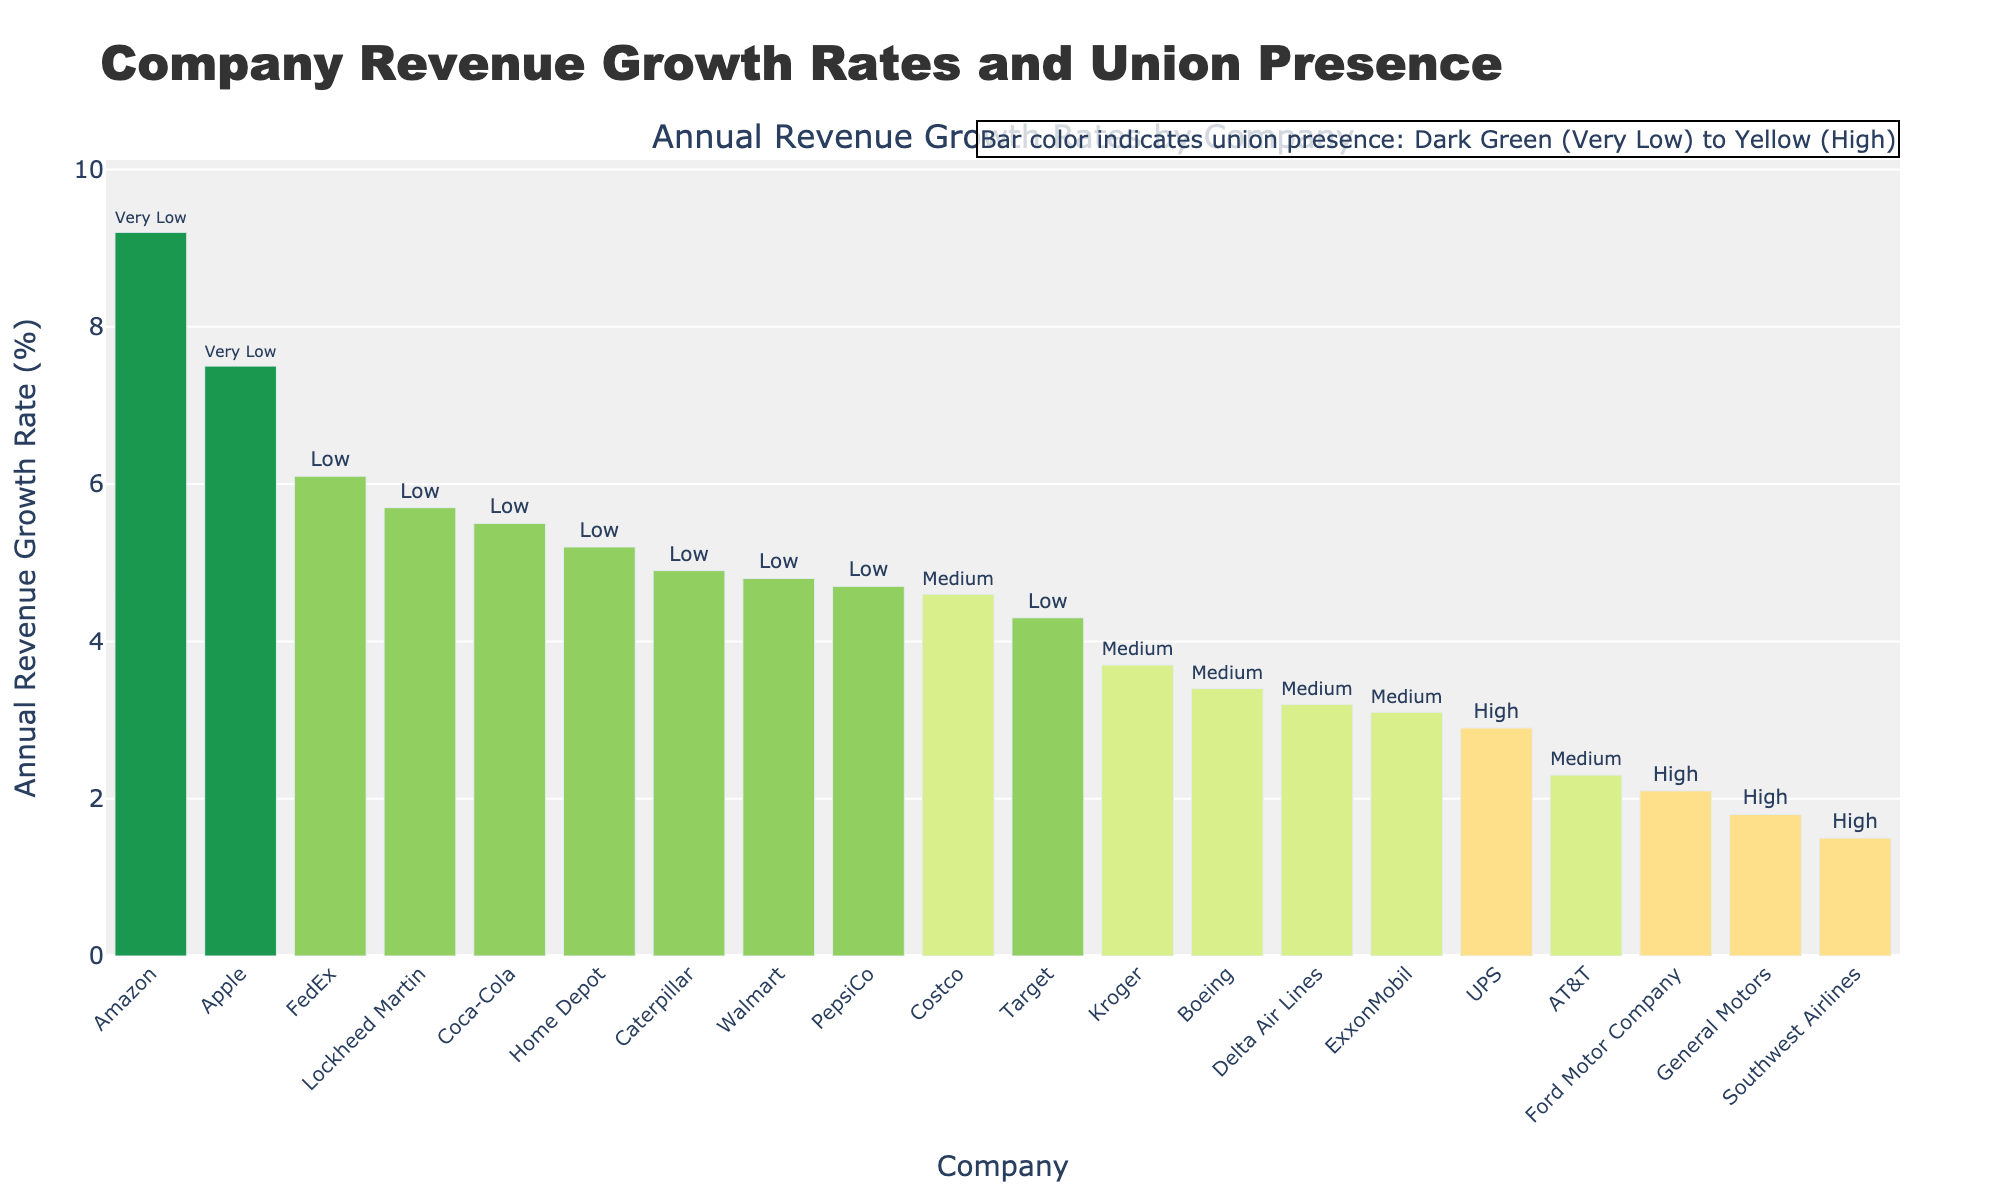Which company has the highest annual revenue growth rate? The bar representing Amazon has the highest height, indicating it has the highest annual revenue growth rate.
Answer: Amazon What is the difference in annual revenue growth rates between UPS and FedEx? The bar for UPS shows a growth rate of 2.9%, and the bar for FedEx shows a growth rate of 6.1%. The difference is 6.1% - 2.9% = 3.2%.
Answer: 3.2% What is the average annual revenue growth rate for companies with low union presence? Companies with low union presence include Walmart, Home Depot, FedEx, Lockheed Martin, Caterpillar, Target, Coca-Cola, and PepsiCo. The average is calculated as (4.8 + 5.2 + 6.1 + 5.7 + 4.9 + 4.3 + 5.5 + 4.7) / 8 = 5.15%.
Answer: 5.15% How does the annual revenue growth rate of Delta Air Lines compare to that of Boeing? Delta Air Lines has a growth rate of 3.2%, while Boeing has a growth rate of 3.4%. Boeing's growth rate is higher by 0.2%.
Answer: Boeing's is higher by 0.2% Which companies have a growth rate higher than 5% but less than 7%? The companies falling in this range are Apple, Home Depot, FedEx, Lockheed Martin, and Coca-Cola.
Answer: Apple, Home Depot, FedEx, Lockheed Martin, Coca-Cola What is the combined annual revenue growth rate for companies with high union presence? Companies with high union presence include UPS, General Motors, Ford Motor Company, and Southwest Airlines. The combined growth rate is 2.9% + 1.8% + 2.1% + 1.5% = 8.3%.
Answer: 8.3% Which union presence category is most common among the companies listed? There are 8 companies with low union presence, 5 with medium, 4 with high, and 2 with very low.
Answer: Low What is the median annual revenue growth rate for companies with medium union presence? Sorted growth rates for medium union presence companies are 2.3, 3.1, 3.2, 3.4, 3.7, 4.6. Median is the average of the 3rd and 4th values: (3.2 + 3.4) / 2 = 3.3%.
Answer: 3.3% What is the visual trend in union presence associated with higher growth rates? The bars representing companies with higher growth rates (e.g., Amazon, Apple) tend to be in darker shades, indicating very low or low union presence.
Answer: Lower union presence Which company with a high union presence has the lowest annual revenue growth rate? The bar for Southwest Airlines with high union presence is the shortest, indicating it has the lowest annual revenue growth rate in that category.
Answer: Southwest Airlines 